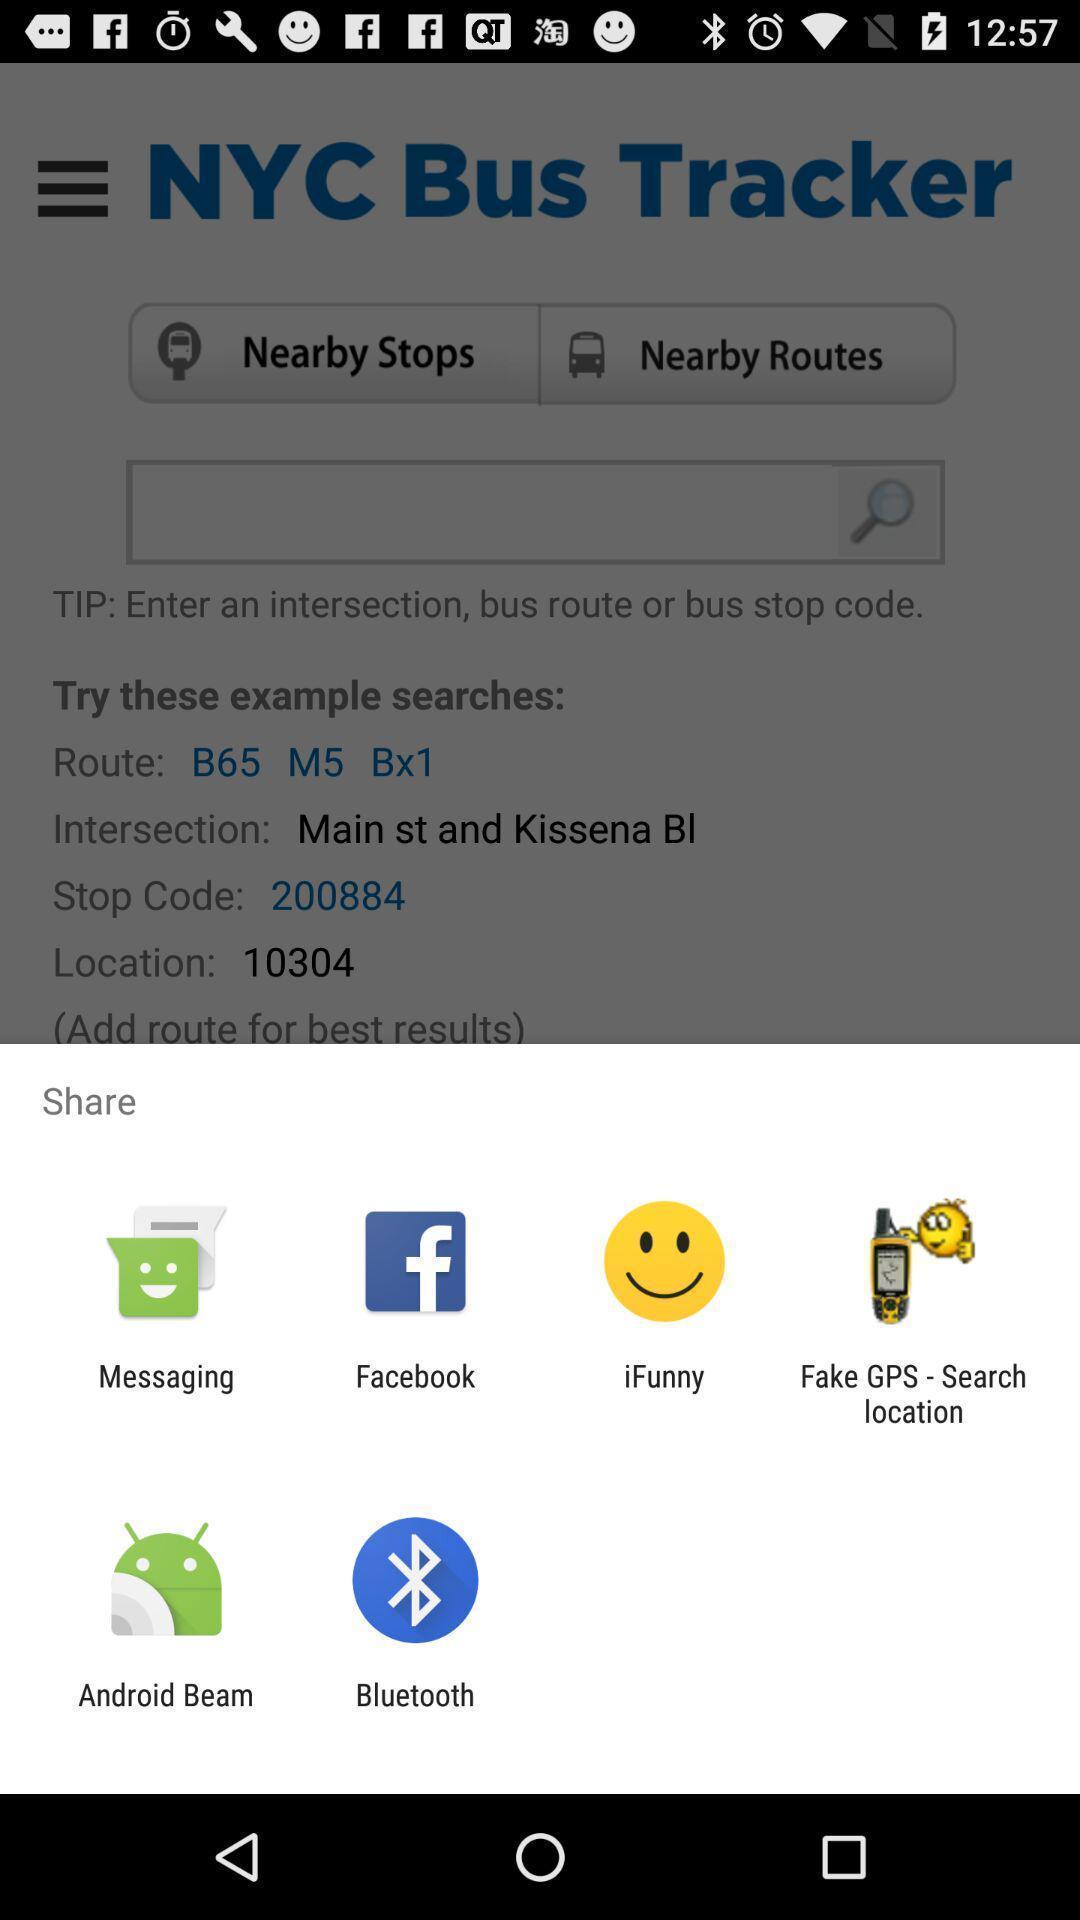Tell me what you see in this picture. Popup showing different options to share the file. 